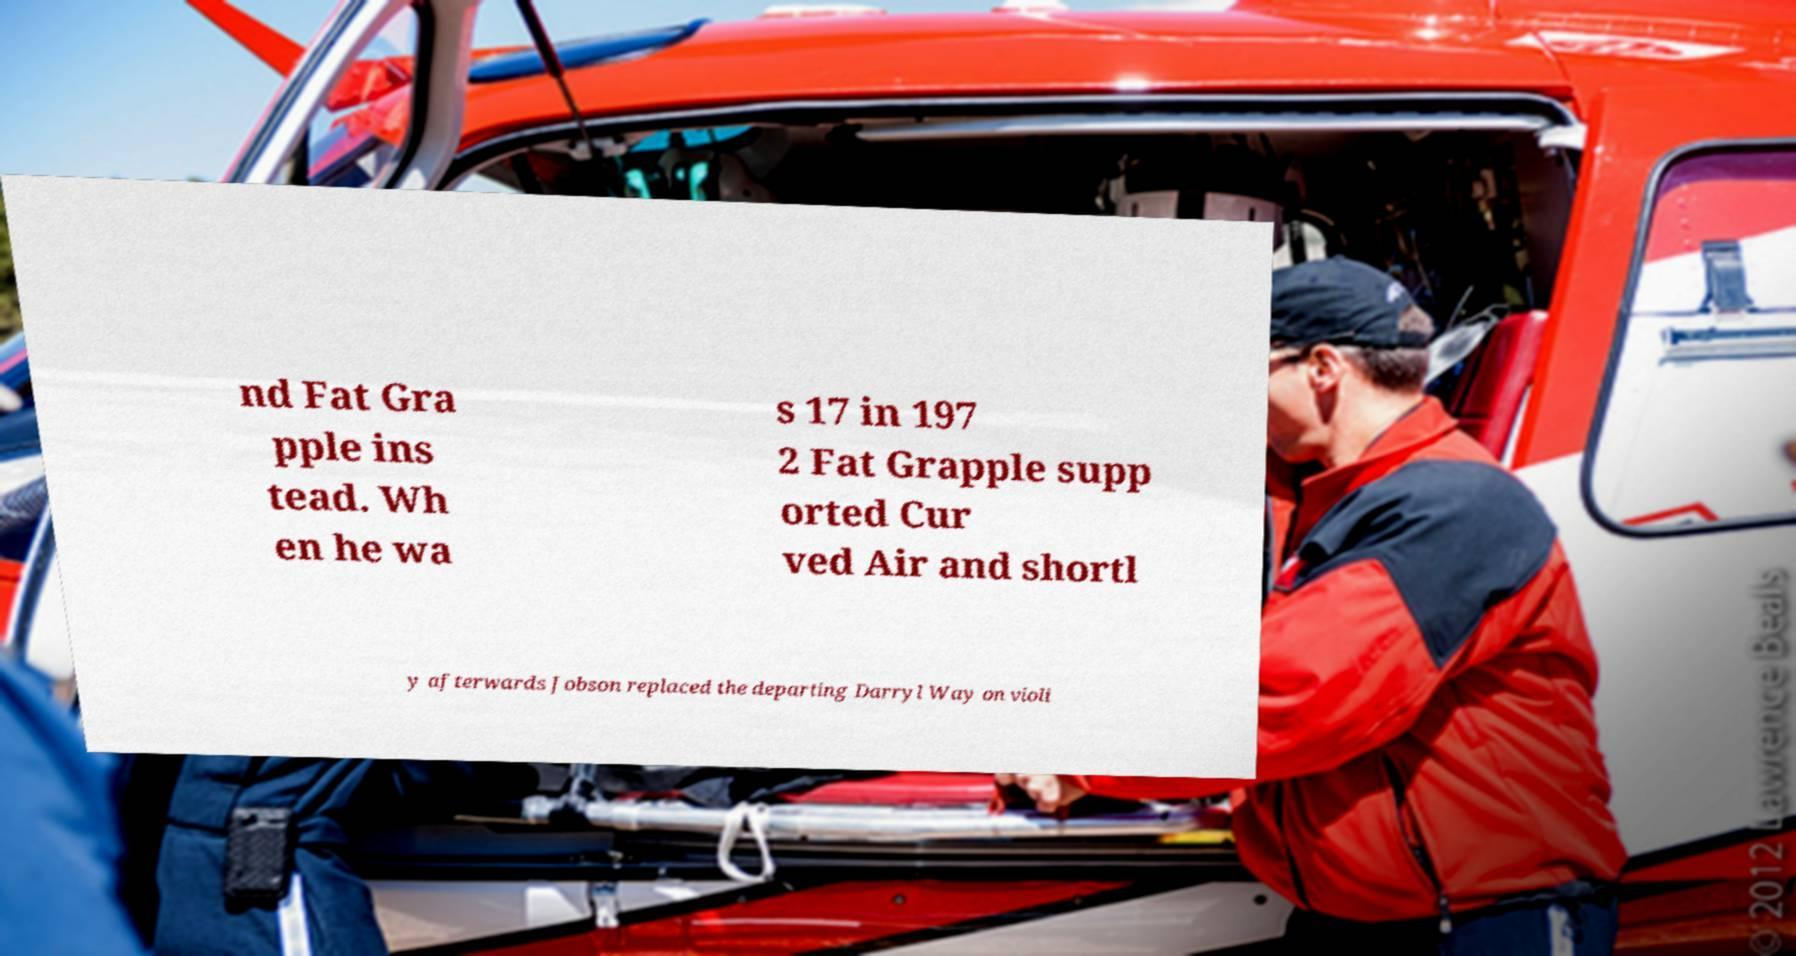Please read and relay the text visible in this image. What does it say? nd Fat Gra pple ins tead. Wh en he wa s 17 in 197 2 Fat Grapple supp orted Cur ved Air and shortl y afterwards Jobson replaced the departing Darryl Way on violi 